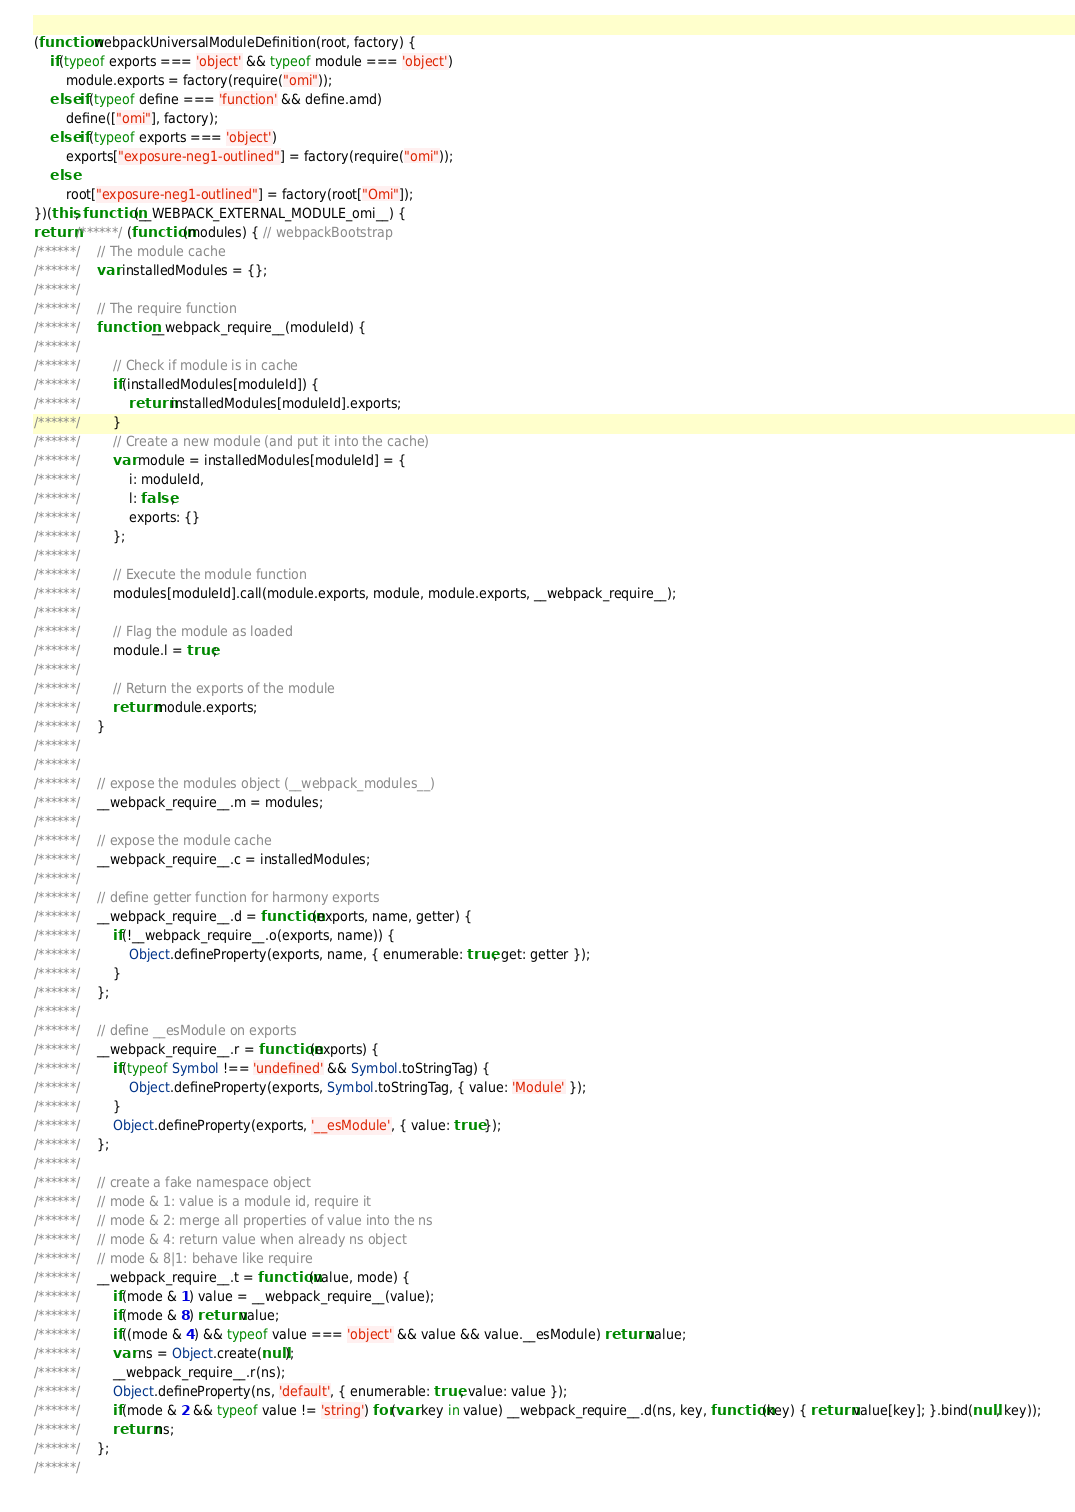Convert code to text. <code><loc_0><loc_0><loc_500><loc_500><_JavaScript_>(function webpackUniversalModuleDefinition(root, factory) {
	if(typeof exports === 'object' && typeof module === 'object')
		module.exports = factory(require("omi"));
	else if(typeof define === 'function' && define.amd)
		define(["omi"], factory);
	else if(typeof exports === 'object')
		exports["exposure-neg1-outlined"] = factory(require("omi"));
	else
		root["exposure-neg1-outlined"] = factory(root["Omi"]);
})(this, function(__WEBPACK_EXTERNAL_MODULE_omi__) {
return /******/ (function(modules) { // webpackBootstrap
/******/ 	// The module cache
/******/ 	var installedModules = {};
/******/
/******/ 	// The require function
/******/ 	function __webpack_require__(moduleId) {
/******/
/******/ 		// Check if module is in cache
/******/ 		if(installedModules[moduleId]) {
/******/ 			return installedModules[moduleId].exports;
/******/ 		}
/******/ 		// Create a new module (and put it into the cache)
/******/ 		var module = installedModules[moduleId] = {
/******/ 			i: moduleId,
/******/ 			l: false,
/******/ 			exports: {}
/******/ 		};
/******/
/******/ 		// Execute the module function
/******/ 		modules[moduleId].call(module.exports, module, module.exports, __webpack_require__);
/******/
/******/ 		// Flag the module as loaded
/******/ 		module.l = true;
/******/
/******/ 		// Return the exports of the module
/******/ 		return module.exports;
/******/ 	}
/******/
/******/
/******/ 	// expose the modules object (__webpack_modules__)
/******/ 	__webpack_require__.m = modules;
/******/
/******/ 	// expose the module cache
/******/ 	__webpack_require__.c = installedModules;
/******/
/******/ 	// define getter function for harmony exports
/******/ 	__webpack_require__.d = function(exports, name, getter) {
/******/ 		if(!__webpack_require__.o(exports, name)) {
/******/ 			Object.defineProperty(exports, name, { enumerable: true, get: getter });
/******/ 		}
/******/ 	};
/******/
/******/ 	// define __esModule on exports
/******/ 	__webpack_require__.r = function(exports) {
/******/ 		if(typeof Symbol !== 'undefined' && Symbol.toStringTag) {
/******/ 			Object.defineProperty(exports, Symbol.toStringTag, { value: 'Module' });
/******/ 		}
/******/ 		Object.defineProperty(exports, '__esModule', { value: true });
/******/ 	};
/******/
/******/ 	// create a fake namespace object
/******/ 	// mode & 1: value is a module id, require it
/******/ 	// mode & 2: merge all properties of value into the ns
/******/ 	// mode & 4: return value when already ns object
/******/ 	// mode & 8|1: behave like require
/******/ 	__webpack_require__.t = function(value, mode) {
/******/ 		if(mode & 1) value = __webpack_require__(value);
/******/ 		if(mode & 8) return value;
/******/ 		if((mode & 4) && typeof value === 'object' && value && value.__esModule) return value;
/******/ 		var ns = Object.create(null);
/******/ 		__webpack_require__.r(ns);
/******/ 		Object.defineProperty(ns, 'default', { enumerable: true, value: value });
/******/ 		if(mode & 2 && typeof value != 'string') for(var key in value) __webpack_require__.d(ns, key, function(key) { return value[key]; }.bind(null, key));
/******/ 		return ns;
/******/ 	};
/******/</code> 